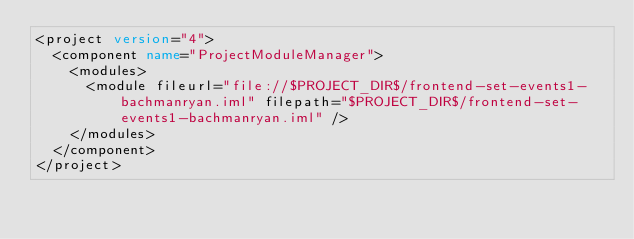Convert code to text. <code><loc_0><loc_0><loc_500><loc_500><_XML_><project version="4">
  <component name="ProjectModuleManager">
    <modules>
      <module fileurl="file://$PROJECT_DIR$/frontend-set-events1-bachmanryan.iml" filepath="$PROJECT_DIR$/frontend-set-events1-bachmanryan.iml" />
    </modules>
  </component>
</project></code> 